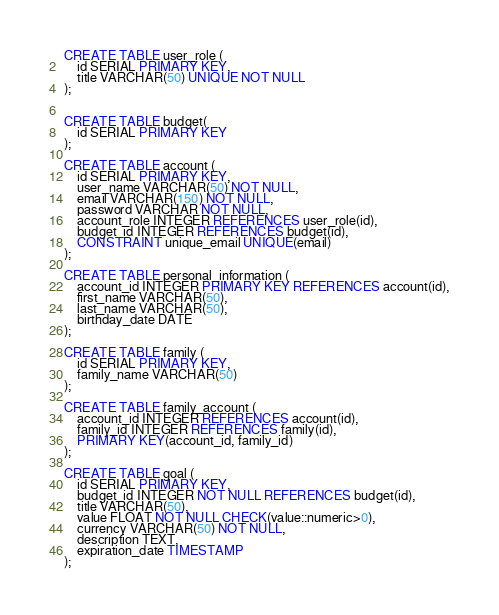Convert code to text. <code><loc_0><loc_0><loc_500><loc_500><_SQL_>CREATE TABLE user_role (
	id SERIAL PRIMARY KEY,
	title VARCHAR(50) UNIQUE NOT NULL 
);


CREATE TABLE budget(
	id SERIAL PRIMARY KEY
);

CREATE TABLE account (
	id SERIAL PRIMARY KEY,
	user_name VARCHAR(50) NOT NULL,
	email VARCHAR(150) NOT NULL,
	password VARCHAR NOT NULL,
	account_role INTEGER REFERENCES user_role(id),
	budget_id INTEGER REFERENCES budget(id),
	CONSTRAINT unique_email UNIQUE(email)
);

CREATE TABLE personal_information (
	account_id INTEGER PRIMARY KEY REFERENCES account(id),
	first_name VARCHAR(50),
	last_name VARCHAR(50),
	birthday_date DATE
);

CREATE TABLE family (
	id SERIAL PRIMARY KEY,
	family_name VARCHAR(50)
);

CREATE TABLE family_account (
	account_id INTEGER REFERENCES account(id),
	family_id INTEGER REFERENCES family(id),
	PRIMARY KEY(account_id, family_id)
);

CREATE TABLE goal (
	id SERIAL PRIMARY KEY,
	budget_id INTEGER NOT NULL REFERENCES budget(id),
	title VARCHAR(50),
	value FLOAT NOT NULL CHECK(value::numeric>0),
	currency VARCHAR(50) NOT NULL,
	description TEXT,
	expiration_date TIMESTAMP
);
</code> 